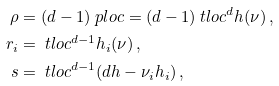Convert formula to latex. <formula><loc_0><loc_0><loc_500><loc_500>\rho & = ( d - 1 ) \ p l o c = ( d - 1 ) \ t l o c ^ { d } h ( \nu ) \, , \\ r _ { i } & = \ t l o c ^ { d - 1 } h _ { i } ( \nu ) \, , \\ s & = \ t l o c ^ { d - 1 } ( d h - \nu _ { i } h _ { i } ) \, ,</formula> 